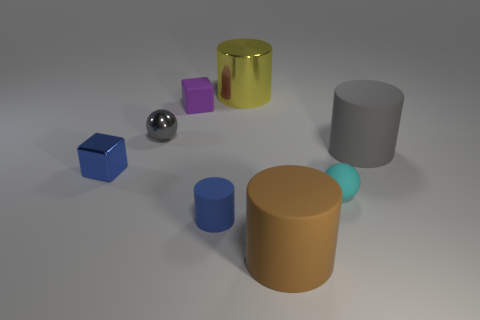Subtract all gray cylinders. How many cylinders are left? 3 Subtract all brown cylinders. How many cylinders are left? 3 Subtract 1 cylinders. How many cylinders are left? 3 Add 2 small cyan cylinders. How many objects exist? 10 Subtract all cyan cylinders. Subtract all green blocks. How many cylinders are left? 4 Add 2 matte cylinders. How many matte cylinders are left? 5 Add 8 tiny brown rubber blocks. How many tiny brown rubber blocks exist? 8 Subtract 0 cyan cubes. How many objects are left? 8 Subtract all yellow metal cylinders. Subtract all tiny cyan rubber spheres. How many objects are left? 6 